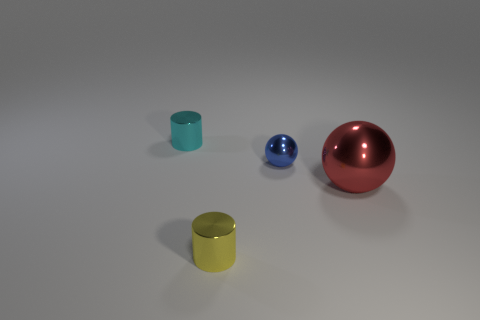Add 2 big green cylinders. How many objects exist? 6 Add 4 red spheres. How many red spheres are left? 5 Add 2 large purple shiny objects. How many large purple shiny objects exist? 2 Subtract 0 cyan balls. How many objects are left? 4 Subtract all big red metal things. Subtract all cyan objects. How many objects are left? 2 